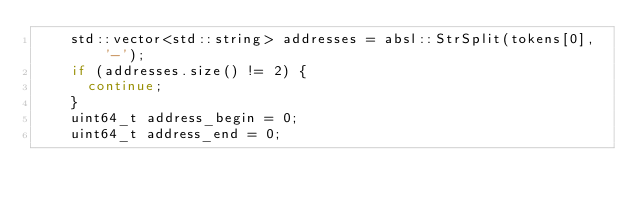<code> <loc_0><loc_0><loc_500><loc_500><_C++_>    std::vector<std::string> addresses = absl::StrSplit(tokens[0], '-');
    if (addresses.size() != 2) {
      continue;
    }
    uint64_t address_begin = 0;
    uint64_t address_end = 0;</code> 